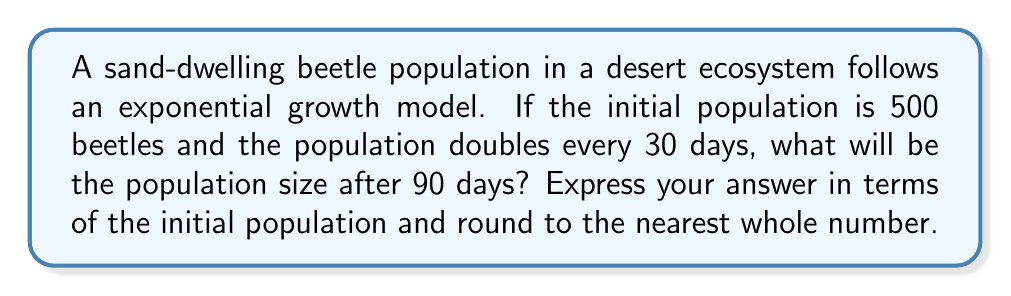Help me with this question. Let's approach this step-by-step:

1) The exponential growth model is given by the formula:
   
   $$ N(t) = N_0 \cdot e^{rt} $$

   Where:
   $N(t)$ is the population at time $t$
   $N_0$ is the initial population
   $r$ is the growth rate
   $t$ is the time

2) We're given that the population doubles every 30 days. We can use this to find $r$:
   
   $$ 2N_0 = N_0 \cdot e^{r \cdot 30} $$
   $$ 2 = e^{30r} $$
   $$ \ln(2) = 30r $$
   $$ r = \frac{\ln(2)}{30} \approx 0.0231 $$

3) Now we can plug in our values:
   $N_0 = 500$ (initial population)
   $r \approx 0.0231$ (growth rate we just calculated)
   $t = 90$ (days)

4) Plugging into our formula:
   
   $$ N(90) = 500 \cdot e^{0.0231 \cdot 90} $$

5) Simplify:
   
   $$ N(90) = 500 \cdot e^{2.079} \approx 4000.54 $$

6) Rounding to the nearest whole number: 4001

7) Express in terms of initial population:
   $4001 \approx 8 \cdot 500 = 8N_0$
Answer: $8N_0$ or 4001 